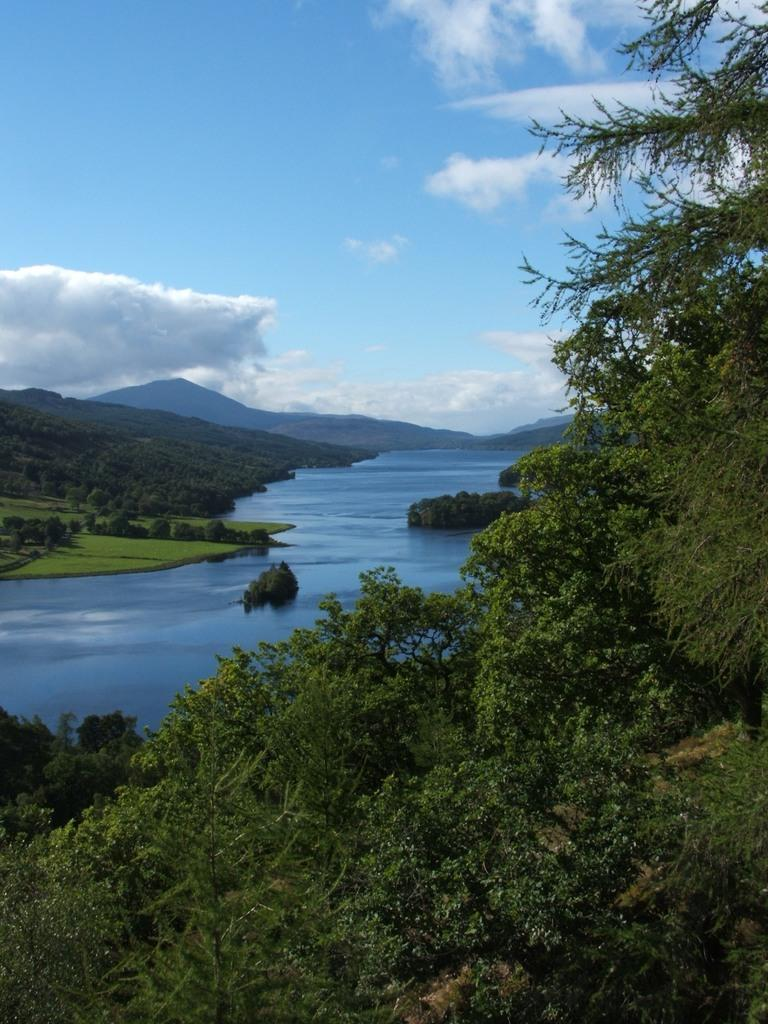What is the main feature in the center of the image? There is a river in the center of the image. What can be seen in the distance behind the river? There are mountains and trees in the background of the image. What type of vegetation is present at the bottom of the image? There is grass at the bottom of the image. How does the river expand in the image? The river does not expand in the image; it is a static image and does not show any changes or movements. 